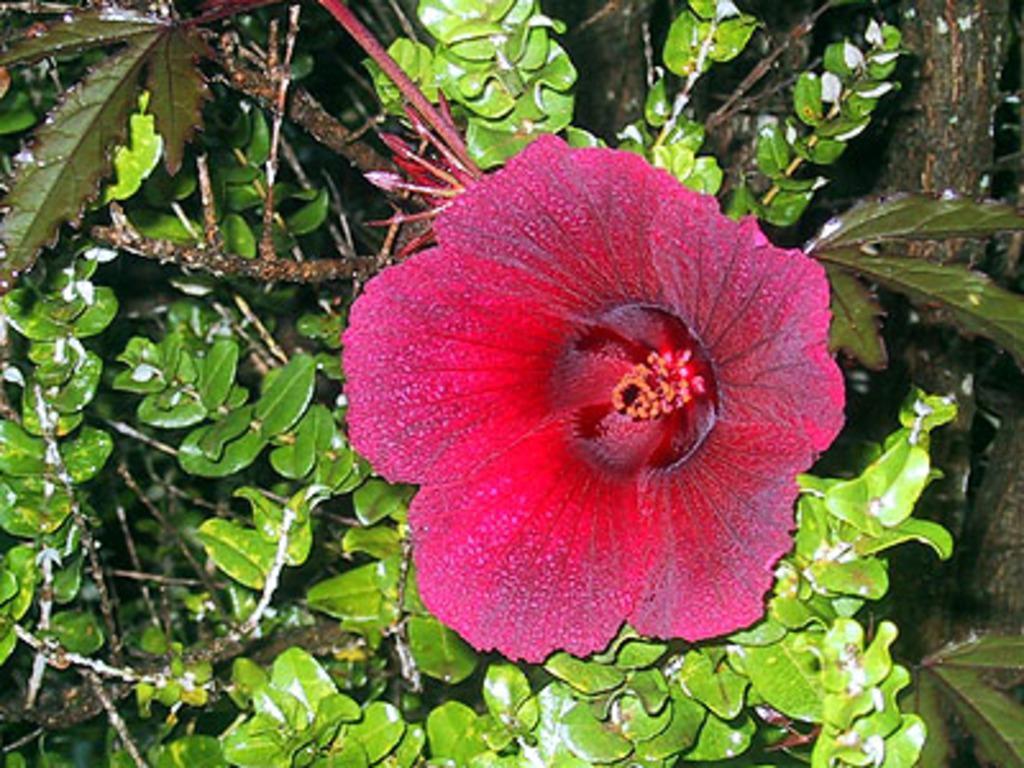Can you describe this image briefly? In this image there is a plant with a hibiscus flower. 